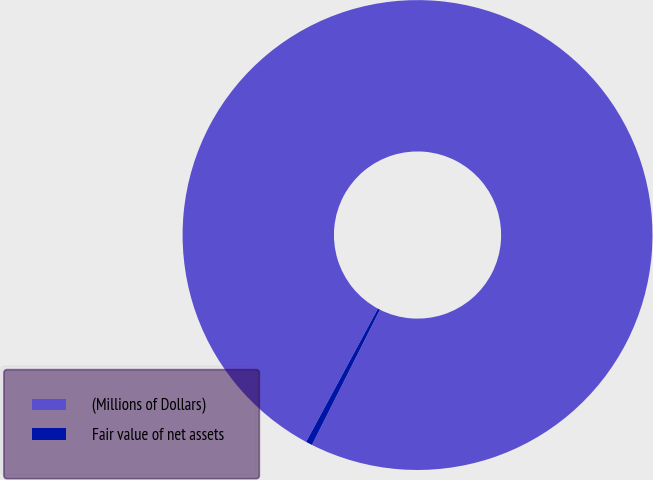<chart> <loc_0><loc_0><loc_500><loc_500><pie_chart><fcel>(Millions of Dollars)<fcel>Fair value of net assets<nl><fcel>99.55%<fcel>0.45%<nl></chart> 